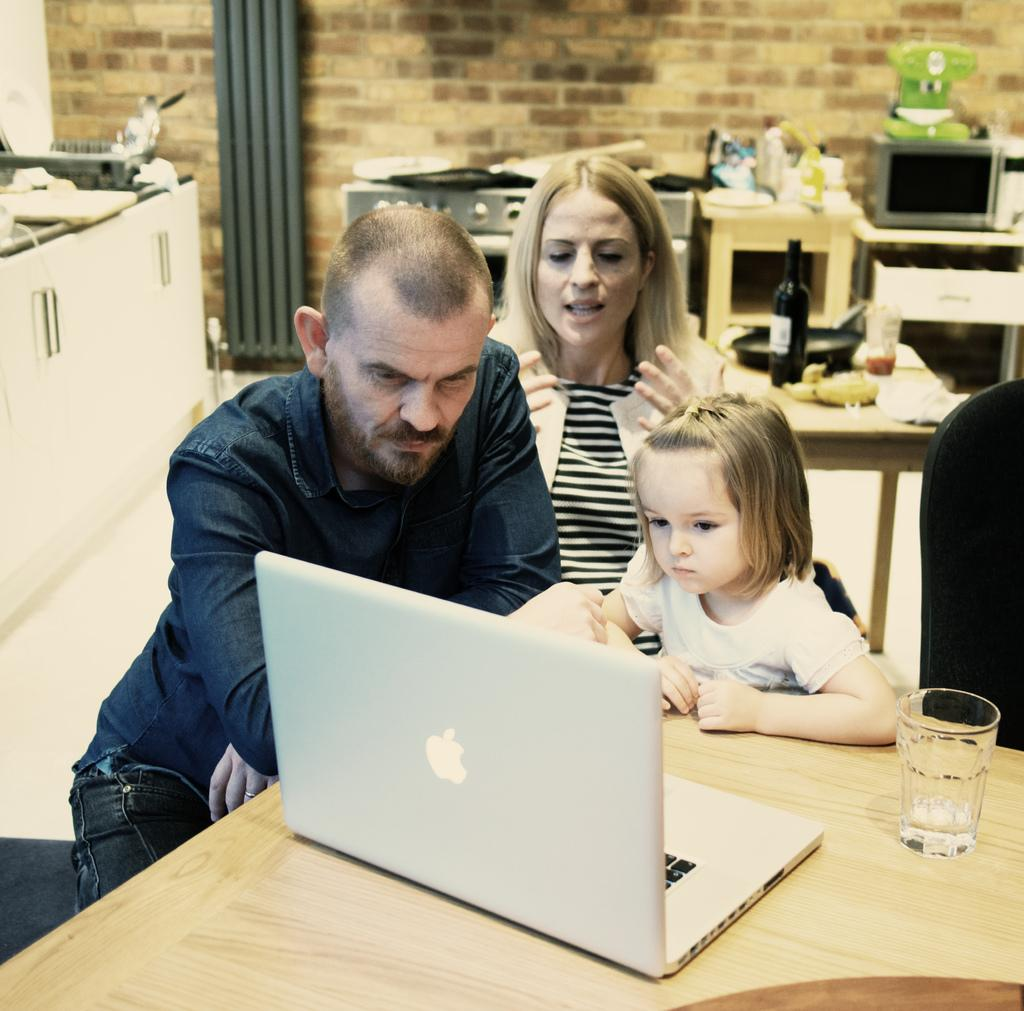How many people are present in the image? There are three people in the image: a man, a woman, and a girl. What objects can be seen on the table in the image? There is a glass and a laptop on the table in the image. What is visible in the background of the image? There is a bottle and other unspecified items near the wall in the background. What might the people in the image be using the laptop for? It is not clear from the image what the people might be using the laptop for. What type of music can be heard coming from the arm in the image? There is no arm or music present in the image. 